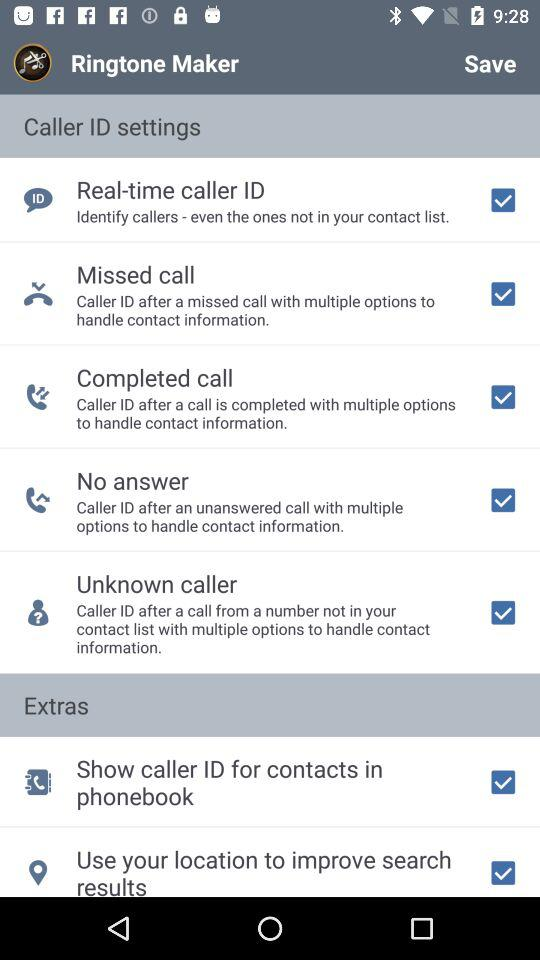How many items are in the Extras section of the Caller ID settings screen?
Answer the question using a single word or phrase. 2 